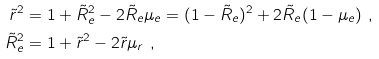<formula> <loc_0><loc_0><loc_500><loc_500>\tilde { r } ^ { 2 } & = 1 + \tilde { R } _ { e } ^ { 2 } - 2 \tilde { R } _ { e } \mu _ { e } = ( 1 - \tilde { R } _ { e } ) ^ { 2 } + 2 \tilde { R } _ { e } ( 1 - \mu _ { e } ) \ , \\ \tilde { R } _ { e } ^ { 2 } & = 1 + \tilde { r } ^ { 2 } - 2 \tilde { r } \mu _ { r } \ ,</formula> 